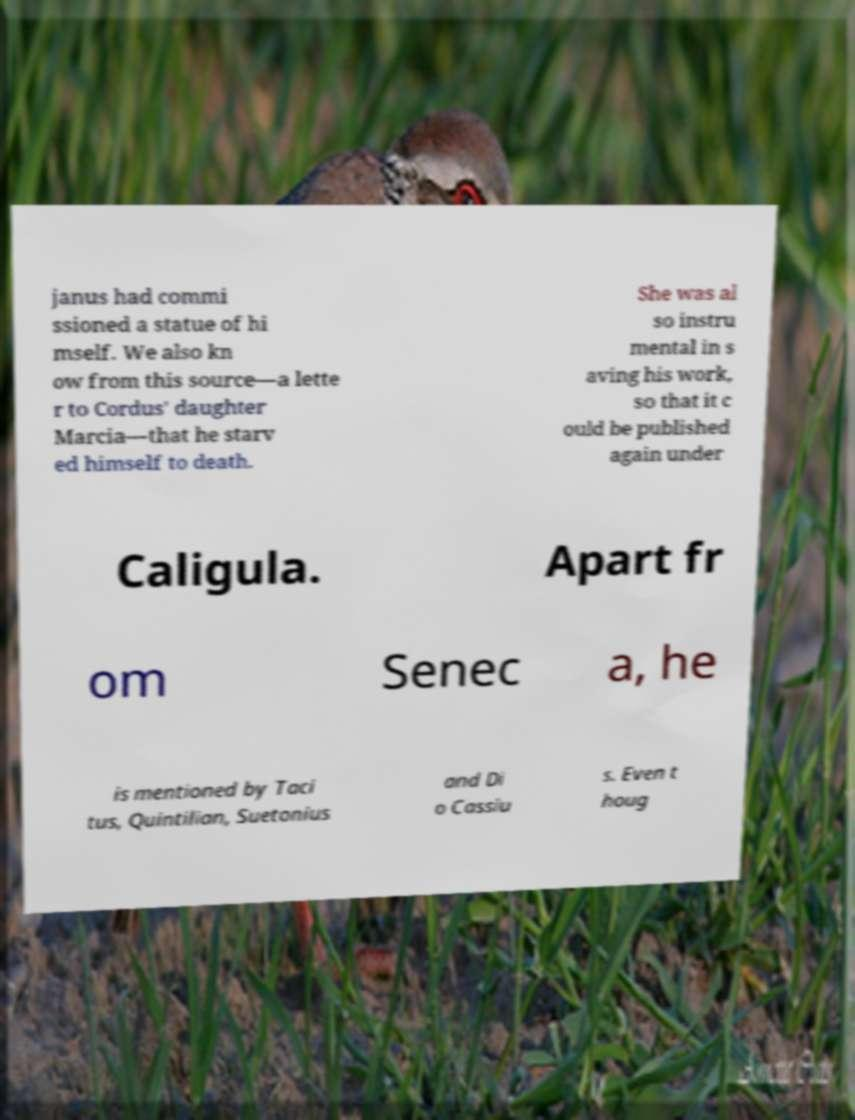What messages or text are displayed in this image? I need them in a readable, typed format. janus had commi ssioned a statue of hi mself. We also kn ow from this source—a lette r to Cordus' daughter Marcia—that he starv ed himself to death. She was al so instru mental in s aving his work, so that it c ould be published again under Caligula. Apart fr om Senec a, he is mentioned by Taci tus, Quintilian, Suetonius and Di o Cassiu s. Even t houg 